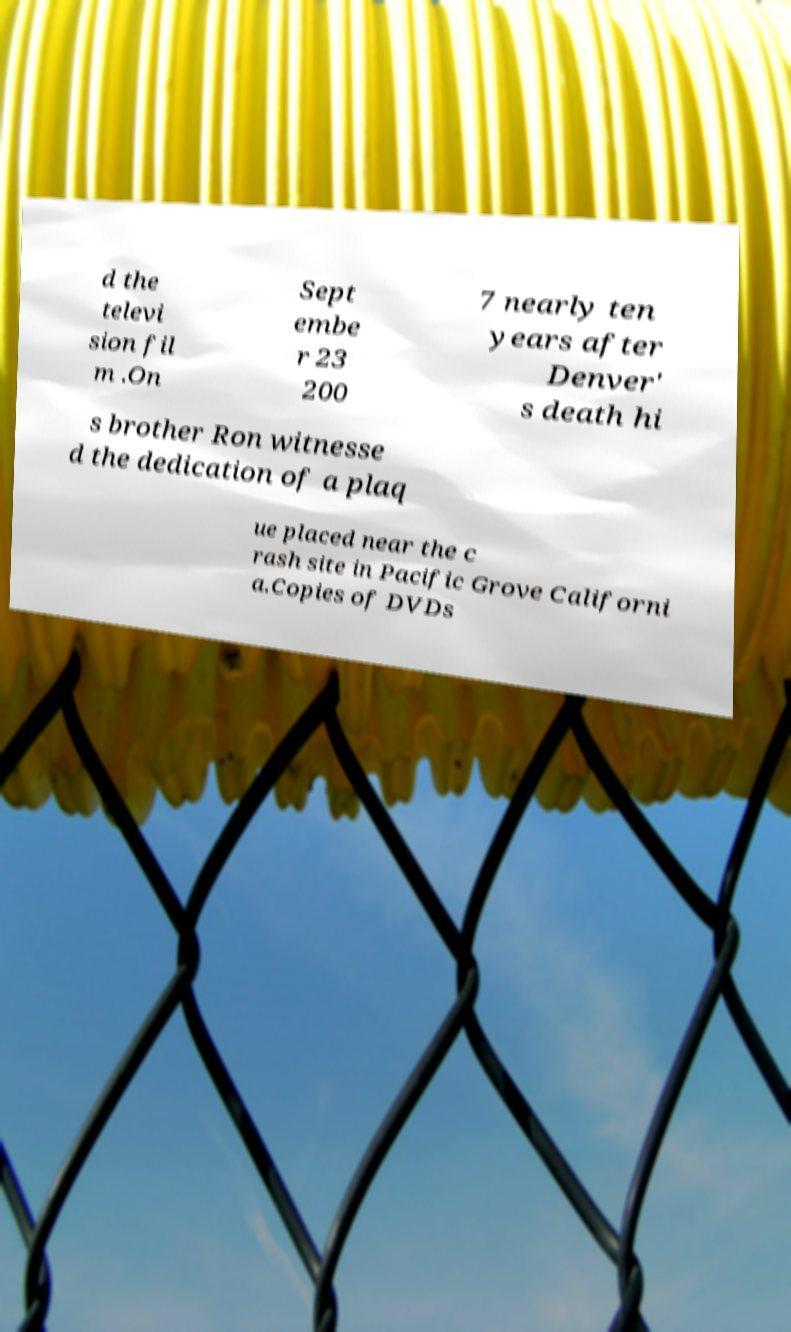There's text embedded in this image that I need extracted. Can you transcribe it verbatim? d the televi sion fil m .On Sept embe r 23 200 7 nearly ten years after Denver' s death hi s brother Ron witnesse d the dedication of a plaq ue placed near the c rash site in Pacific Grove Californi a.Copies of DVDs 